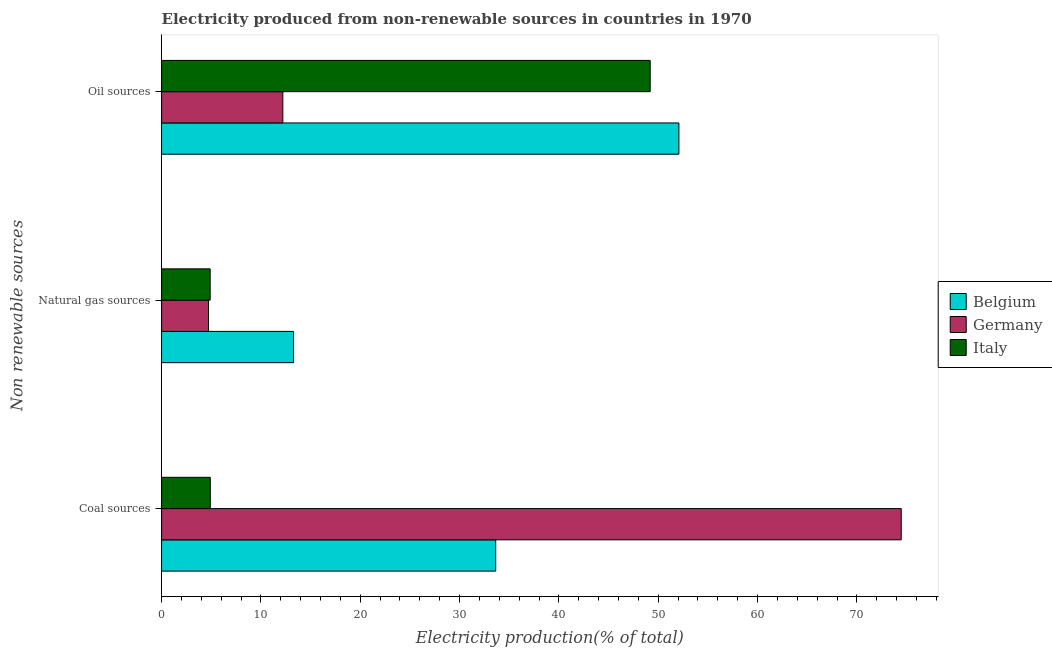Are the number of bars per tick equal to the number of legend labels?
Provide a short and direct response. Yes. Are the number of bars on each tick of the Y-axis equal?
Offer a very short reply. Yes. How many bars are there on the 2nd tick from the top?
Provide a succinct answer. 3. What is the label of the 2nd group of bars from the top?
Your answer should be compact. Natural gas sources. What is the percentage of electricity produced by oil sources in Belgium?
Keep it short and to the point. 52.08. Across all countries, what is the maximum percentage of electricity produced by coal?
Give a very brief answer. 74.46. Across all countries, what is the minimum percentage of electricity produced by coal?
Keep it short and to the point. 4.9. In which country was the percentage of electricity produced by oil sources minimum?
Your answer should be compact. Germany. What is the total percentage of electricity produced by natural gas in the graph?
Keep it short and to the point. 22.9. What is the difference between the percentage of electricity produced by oil sources in Belgium and that in Italy?
Provide a short and direct response. 2.89. What is the difference between the percentage of electricity produced by natural gas in Belgium and the percentage of electricity produced by coal in Germany?
Make the answer very short. -61.18. What is the average percentage of electricity produced by natural gas per country?
Your answer should be compact. 7.63. What is the difference between the percentage of electricity produced by coal and percentage of electricity produced by natural gas in Germany?
Provide a short and direct response. 69.74. In how many countries, is the percentage of electricity produced by coal greater than 2 %?
Your response must be concise. 3. What is the ratio of the percentage of electricity produced by oil sources in Belgium to that in Germany?
Offer a very short reply. 4.27. Is the percentage of electricity produced by coal in Italy less than that in Belgium?
Offer a terse response. Yes. What is the difference between the highest and the second highest percentage of electricity produced by natural gas?
Ensure brevity in your answer.  8.39. What is the difference between the highest and the lowest percentage of electricity produced by coal?
Give a very brief answer. 69.56. In how many countries, is the percentage of electricity produced by oil sources greater than the average percentage of electricity produced by oil sources taken over all countries?
Make the answer very short. 2. Is the sum of the percentage of electricity produced by coal in Belgium and Italy greater than the maximum percentage of electricity produced by oil sources across all countries?
Ensure brevity in your answer.  No. Is it the case that in every country, the sum of the percentage of electricity produced by coal and percentage of electricity produced by natural gas is greater than the percentage of electricity produced by oil sources?
Give a very brief answer. No. Are all the bars in the graph horizontal?
Your answer should be very brief. Yes. What is the difference between two consecutive major ticks on the X-axis?
Your answer should be compact. 10. Does the graph contain any zero values?
Keep it short and to the point. No. Does the graph contain grids?
Make the answer very short. No. Where does the legend appear in the graph?
Ensure brevity in your answer.  Center right. How many legend labels are there?
Your answer should be very brief. 3. How are the legend labels stacked?
Provide a short and direct response. Vertical. What is the title of the graph?
Make the answer very short. Electricity produced from non-renewable sources in countries in 1970. Does "Guam" appear as one of the legend labels in the graph?
Ensure brevity in your answer.  No. What is the label or title of the Y-axis?
Provide a short and direct response. Non renewable sources. What is the Electricity production(% of total) of Belgium in Coal sources?
Give a very brief answer. 33.64. What is the Electricity production(% of total) in Germany in Coal sources?
Keep it short and to the point. 74.46. What is the Electricity production(% of total) of Italy in Coal sources?
Provide a succinct answer. 4.9. What is the Electricity production(% of total) of Belgium in Natural gas sources?
Make the answer very short. 13.29. What is the Electricity production(% of total) in Germany in Natural gas sources?
Offer a terse response. 4.72. What is the Electricity production(% of total) in Italy in Natural gas sources?
Offer a very short reply. 4.89. What is the Electricity production(% of total) in Belgium in Oil sources?
Make the answer very short. 52.08. What is the Electricity production(% of total) of Germany in Oil sources?
Keep it short and to the point. 12.21. What is the Electricity production(% of total) of Italy in Oil sources?
Give a very brief answer. 49.19. Across all Non renewable sources, what is the maximum Electricity production(% of total) of Belgium?
Offer a terse response. 52.08. Across all Non renewable sources, what is the maximum Electricity production(% of total) in Germany?
Provide a short and direct response. 74.46. Across all Non renewable sources, what is the maximum Electricity production(% of total) in Italy?
Offer a terse response. 49.19. Across all Non renewable sources, what is the minimum Electricity production(% of total) of Belgium?
Ensure brevity in your answer.  13.29. Across all Non renewable sources, what is the minimum Electricity production(% of total) in Germany?
Give a very brief answer. 4.72. Across all Non renewable sources, what is the minimum Electricity production(% of total) of Italy?
Provide a short and direct response. 4.89. What is the total Electricity production(% of total) in Belgium in the graph?
Keep it short and to the point. 99.01. What is the total Electricity production(% of total) in Germany in the graph?
Your answer should be very brief. 91.4. What is the total Electricity production(% of total) in Italy in the graph?
Provide a succinct answer. 58.99. What is the difference between the Electricity production(% of total) of Belgium in Coal sources and that in Natural gas sources?
Provide a succinct answer. 20.36. What is the difference between the Electricity production(% of total) in Germany in Coal sources and that in Natural gas sources?
Keep it short and to the point. 69.74. What is the difference between the Electricity production(% of total) in Italy in Coal sources and that in Natural gas sources?
Ensure brevity in your answer.  0.01. What is the difference between the Electricity production(% of total) of Belgium in Coal sources and that in Oil sources?
Provide a short and direct response. -18.44. What is the difference between the Electricity production(% of total) of Germany in Coal sources and that in Oil sources?
Give a very brief answer. 62.26. What is the difference between the Electricity production(% of total) in Italy in Coal sources and that in Oil sources?
Offer a terse response. -44.29. What is the difference between the Electricity production(% of total) in Belgium in Natural gas sources and that in Oil sources?
Provide a succinct answer. -38.8. What is the difference between the Electricity production(% of total) in Germany in Natural gas sources and that in Oil sources?
Give a very brief answer. -7.48. What is the difference between the Electricity production(% of total) of Italy in Natural gas sources and that in Oil sources?
Keep it short and to the point. -44.3. What is the difference between the Electricity production(% of total) in Belgium in Coal sources and the Electricity production(% of total) in Germany in Natural gas sources?
Offer a terse response. 28.92. What is the difference between the Electricity production(% of total) in Belgium in Coal sources and the Electricity production(% of total) in Italy in Natural gas sources?
Provide a succinct answer. 28.75. What is the difference between the Electricity production(% of total) of Germany in Coal sources and the Electricity production(% of total) of Italy in Natural gas sources?
Your response must be concise. 69.57. What is the difference between the Electricity production(% of total) in Belgium in Coal sources and the Electricity production(% of total) in Germany in Oil sources?
Offer a very short reply. 21.43. What is the difference between the Electricity production(% of total) in Belgium in Coal sources and the Electricity production(% of total) in Italy in Oil sources?
Keep it short and to the point. -15.55. What is the difference between the Electricity production(% of total) in Germany in Coal sources and the Electricity production(% of total) in Italy in Oil sources?
Your response must be concise. 25.27. What is the difference between the Electricity production(% of total) in Belgium in Natural gas sources and the Electricity production(% of total) in Germany in Oil sources?
Ensure brevity in your answer.  1.08. What is the difference between the Electricity production(% of total) of Belgium in Natural gas sources and the Electricity production(% of total) of Italy in Oil sources?
Ensure brevity in your answer.  -35.91. What is the difference between the Electricity production(% of total) of Germany in Natural gas sources and the Electricity production(% of total) of Italy in Oil sources?
Keep it short and to the point. -44.47. What is the average Electricity production(% of total) of Belgium per Non renewable sources?
Ensure brevity in your answer.  33. What is the average Electricity production(% of total) of Germany per Non renewable sources?
Give a very brief answer. 30.47. What is the average Electricity production(% of total) in Italy per Non renewable sources?
Make the answer very short. 19.66. What is the difference between the Electricity production(% of total) in Belgium and Electricity production(% of total) in Germany in Coal sources?
Provide a succinct answer. -40.82. What is the difference between the Electricity production(% of total) of Belgium and Electricity production(% of total) of Italy in Coal sources?
Make the answer very short. 28.74. What is the difference between the Electricity production(% of total) in Germany and Electricity production(% of total) in Italy in Coal sources?
Ensure brevity in your answer.  69.56. What is the difference between the Electricity production(% of total) of Belgium and Electricity production(% of total) of Germany in Natural gas sources?
Ensure brevity in your answer.  8.56. What is the difference between the Electricity production(% of total) of Belgium and Electricity production(% of total) of Italy in Natural gas sources?
Your answer should be compact. 8.39. What is the difference between the Electricity production(% of total) in Germany and Electricity production(% of total) in Italy in Natural gas sources?
Provide a short and direct response. -0.17. What is the difference between the Electricity production(% of total) in Belgium and Electricity production(% of total) in Germany in Oil sources?
Keep it short and to the point. 39.87. What is the difference between the Electricity production(% of total) in Belgium and Electricity production(% of total) in Italy in Oil sources?
Offer a very short reply. 2.89. What is the difference between the Electricity production(% of total) of Germany and Electricity production(% of total) of Italy in Oil sources?
Provide a short and direct response. -36.98. What is the ratio of the Electricity production(% of total) in Belgium in Coal sources to that in Natural gas sources?
Offer a very short reply. 2.53. What is the ratio of the Electricity production(% of total) in Germany in Coal sources to that in Natural gas sources?
Your response must be concise. 15.76. What is the ratio of the Electricity production(% of total) in Belgium in Coal sources to that in Oil sources?
Provide a short and direct response. 0.65. What is the ratio of the Electricity production(% of total) of Germany in Coal sources to that in Oil sources?
Give a very brief answer. 6.1. What is the ratio of the Electricity production(% of total) of Italy in Coal sources to that in Oil sources?
Ensure brevity in your answer.  0.1. What is the ratio of the Electricity production(% of total) of Belgium in Natural gas sources to that in Oil sources?
Your answer should be very brief. 0.26. What is the ratio of the Electricity production(% of total) in Germany in Natural gas sources to that in Oil sources?
Offer a terse response. 0.39. What is the ratio of the Electricity production(% of total) in Italy in Natural gas sources to that in Oil sources?
Your response must be concise. 0.1. What is the difference between the highest and the second highest Electricity production(% of total) in Belgium?
Your response must be concise. 18.44. What is the difference between the highest and the second highest Electricity production(% of total) of Germany?
Offer a very short reply. 62.26. What is the difference between the highest and the second highest Electricity production(% of total) in Italy?
Keep it short and to the point. 44.29. What is the difference between the highest and the lowest Electricity production(% of total) of Belgium?
Keep it short and to the point. 38.8. What is the difference between the highest and the lowest Electricity production(% of total) of Germany?
Your response must be concise. 69.74. What is the difference between the highest and the lowest Electricity production(% of total) of Italy?
Ensure brevity in your answer.  44.3. 